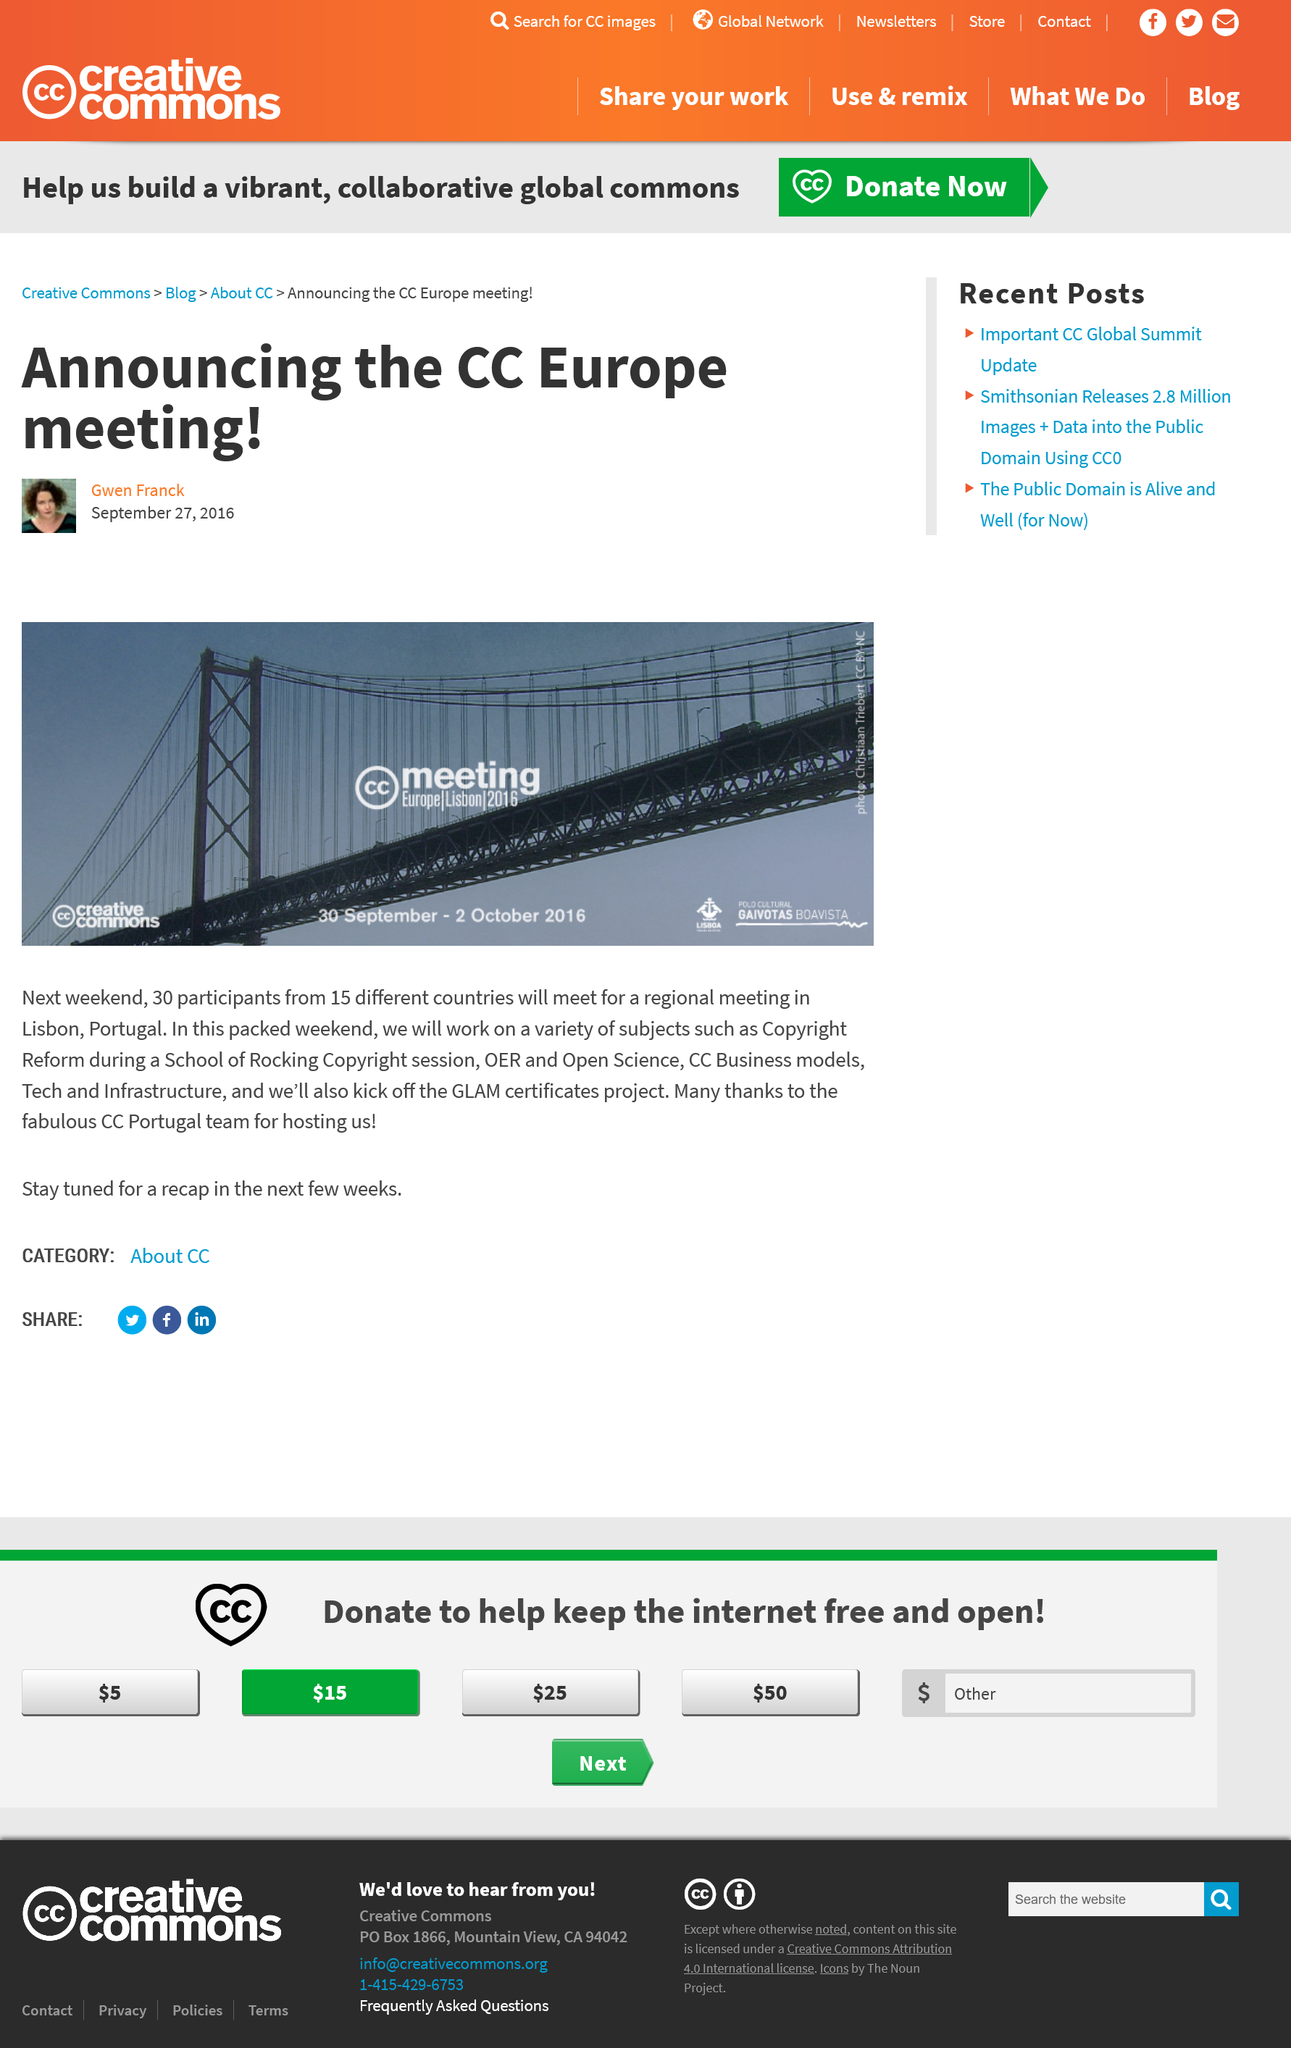Identify some key points in this picture. The CC Europe meeting took place from 30 September to 2 October 2016. Thirty participants will be attending the CC Europe meeting. The article was created by Gwen Franck. 